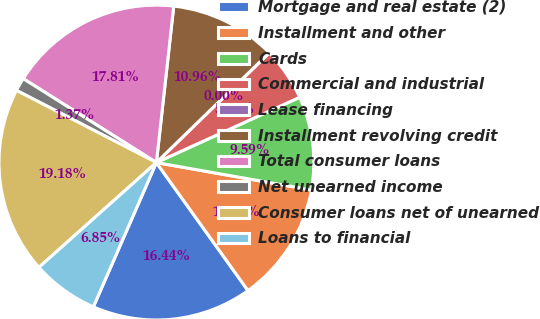Convert chart to OTSL. <chart><loc_0><loc_0><loc_500><loc_500><pie_chart><fcel>Mortgage and real estate (2)<fcel>Installment and other<fcel>Cards<fcel>Commercial and industrial<fcel>Lease financing<fcel>Installment revolving credit<fcel>Total consumer loans<fcel>Net unearned income<fcel>Consumer loans net of unearned<fcel>Loans to financial<nl><fcel>16.44%<fcel>12.33%<fcel>9.59%<fcel>5.48%<fcel>0.0%<fcel>10.96%<fcel>17.81%<fcel>1.37%<fcel>19.18%<fcel>6.85%<nl></chart> 